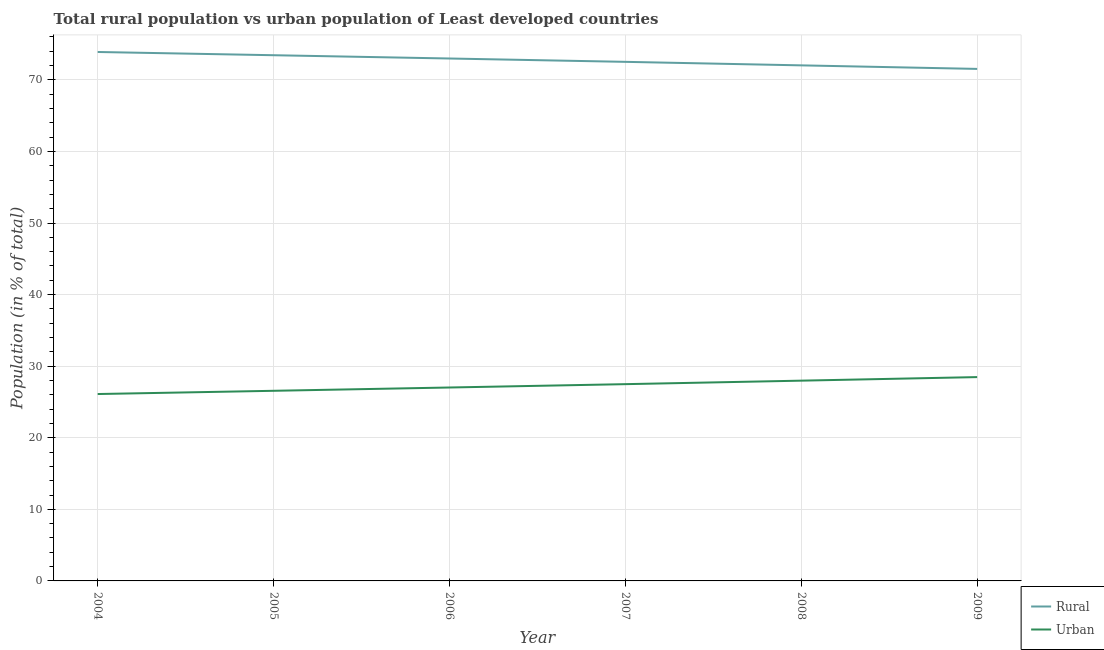Does the line corresponding to urban population intersect with the line corresponding to rural population?
Offer a terse response. No. What is the urban population in 2007?
Your answer should be compact. 27.49. Across all years, what is the maximum rural population?
Offer a very short reply. 73.89. Across all years, what is the minimum urban population?
Give a very brief answer. 26.11. What is the total urban population in the graph?
Your response must be concise. 163.63. What is the difference between the rural population in 2004 and that in 2007?
Offer a terse response. 1.38. What is the difference between the rural population in 2004 and the urban population in 2007?
Ensure brevity in your answer.  46.4. What is the average urban population per year?
Provide a short and direct response. 27.27. In the year 2009, what is the difference between the rural population and urban population?
Give a very brief answer. 43.05. What is the ratio of the rural population in 2005 to that in 2009?
Give a very brief answer. 1.03. Is the urban population in 2005 less than that in 2006?
Your answer should be compact. Yes. What is the difference between the highest and the second highest rural population?
Give a very brief answer. 0.45. What is the difference between the highest and the lowest urban population?
Give a very brief answer. 2.36. In how many years, is the urban population greater than the average urban population taken over all years?
Offer a terse response. 3. Is the sum of the urban population in 2006 and 2009 greater than the maximum rural population across all years?
Provide a succinct answer. No. Is the rural population strictly less than the urban population over the years?
Keep it short and to the point. No. How many lines are there?
Keep it short and to the point. 2. How many years are there in the graph?
Your answer should be very brief. 6. What is the difference between two consecutive major ticks on the Y-axis?
Offer a very short reply. 10. Are the values on the major ticks of Y-axis written in scientific E-notation?
Provide a short and direct response. No. Where does the legend appear in the graph?
Offer a terse response. Bottom right. How many legend labels are there?
Keep it short and to the point. 2. How are the legend labels stacked?
Offer a terse response. Vertical. What is the title of the graph?
Give a very brief answer. Total rural population vs urban population of Least developed countries. What is the label or title of the Y-axis?
Make the answer very short. Population (in % of total). What is the Population (in % of total) of Rural in 2004?
Give a very brief answer. 73.89. What is the Population (in % of total) of Urban in 2004?
Offer a very short reply. 26.11. What is the Population (in % of total) of Rural in 2005?
Ensure brevity in your answer.  73.44. What is the Population (in % of total) in Urban in 2005?
Make the answer very short. 26.56. What is the Population (in % of total) in Rural in 2006?
Give a very brief answer. 72.98. What is the Population (in % of total) of Urban in 2006?
Ensure brevity in your answer.  27.02. What is the Population (in % of total) in Rural in 2007?
Provide a succinct answer. 72.51. What is the Population (in % of total) of Urban in 2007?
Your answer should be compact. 27.49. What is the Population (in % of total) in Rural in 2008?
Keep it short and to the point. 72.02. What is the Population (in % of total) in Urban in 2008?
Keep it short and to the point. 27.98. What is the Population (in % of total) of Rural in 2009?
Keep it short and to the point. 71.53. What is the Population (in % of total) of Urban in 2009?
Your answer should be very brief. 28.47. Across all years, what is the maximum Population (in % of total) in Rural?
Offer a terse response. 73.89. Across all years, what is the maximum Population (in % of total) of Urban?
Give a very brief answer. 28.47. Across all years, what is the minimum Population (in % of total) in Rural?
Make the answer very short. 71.53. Across all years, what is the minimum Population (in % of total) in Urban?
Keep it short and to the point. 26.11. What is the total Population (in % of total) in Rural in the graph?
Offer a terse response. 436.37. What is the total Population (in % of total) in Urban in the graph?
Make the answer very short. 163.63. What is the difference between the Population (in % of total) of Rural in 2004 and that in 2005?
Provide a short and direct response. 0.45. What is the difference between the Population (in % of total) of Urban in 2004 and that in 2005?
Make the answer very short. -0.45. What is the difference between the Population (in % of total) in Rural in 2004 and that in 2006?
Your response must be concise. 0.91. What is the difference between the Population (in % of total) in Urban in 2004 and that in 2006?
Offer a terse response. -0.91. What is the difference between the Population (in % of total) in Rural in 2004 and that in 2007?
Your answer should be very brief. 1.38. What is the difference between the Population (in % of total) of Urban in 2004 and that in 2007?
Make the answer very short. -1.38. What is the difference between the Population (in % of total) of Rural in 2004 and that in 2008?
Provide a succinct answer. 1.87. What is the difference between the Population (in % of total) in Urban in 2004 and that in 2008?
Your answer should be very brief. -1.87. What is the difference between the Population (in % of total) of Rural in 2004 and that in 2009?
Your answer should be very brief. 2.36. What is the difference between the Population (in % of total) in Urban in 2004 and that in 2009?
Make the answer very short. -2.36. What is the difference between the Population (in % of total) in Rural in 2005 and that in 2006?
Provide a succinct answer. 0.46. What is the difference between the Population (in % of total) in Urban in 2005 and that in 2006?
Provide a short and direct response. -0.46. What is the difference between the Population (in % of total) of Rural in 2005 and that in 2007?
Provide a short and direct response. 0.93. What is the difference between the Population (in % of total) of Urban in 2005 and that in 2007?
Make the answer very short. -0.93. What is the difference between the Population (in % of total) in Rural in 2005 and that in 2008?
Keep it short and to the point. 1.42. What is the difference between the Population (in % of total) in Urban in 2005 and that in 2008?
Keep it short and to the point. -1.42. What is the difference between the Population (in % of total) of Rural in 2005 and that in 2009?
Your answer should be compact. 1.91. What is the difference between the Population (in % of total) of Urban in 2005 and that in 2009?
Your answer should be compact. -1.91. What is the difference between the Population (in % of total) of Rural in 2006 and that in 2007?
Offer a very short reply. 0.47. What is the difference between the Population (in % of total) of Urban in 2006 and that in 2007?
Offer a terse response. -0.47. What is the difference between the Population (in % of total) of Rural in 2006 and that in 2008?
Keep it short and to the point. 0.96. What is the difference between the Population (in % of total) of Urban in 2006 and that in 2008?
Offer a terse response. -0.96. What is the difference between the Population (in % of total) in Rural in 2006 and that in 2009?
Make the answer very short. 1.45. What is the difference between the Population (in % of total) in Urban in 2006 and that in 2009?
Your response must be concise. -1.45. What is the difference between the Population (in % of total) of Rural in 2007 and that in 2008?
Make the answer very short. 0.49. What is the difference between the Population (in % of total) of Urban in 2007 and that in 2008?
Ensure brevity in your answer.  -0.49. What is the difference between the Population (in % of total) in Rural in 2007 and that in 2009?
Provide a short and direct response. 0.99. What is the difference between the Population (in % of total) in Urban in 2007 and that in 2009?
Your answer should be very brief. -0.99. What is the difference between the Population (in % of total) of Rural in 2008 and that in 2009?
Your answer should be compact. 0.5. What is the difference between the Population (in % of total) in Urban in 2008 and that in 2009?
Provide a succinct answer. -0.5. What is the difference between the Population (in % of total) in Rural in 2004 and the Population (in % of total) in Urban in 2005?
Offer a terse response. 47.33. What is the difference between the Population (in % of total) in Rural in 2004 and the Population (in % of total) in Urban in 2006?
Your answer should be compact. 46.87. What is the difference between the Population (in % of total) of Rural in 2004 and the Population (in % of total) of Urban in 2007?
Provide a short and direct response. 46.4. What is the difference between the Population (in % of total) in Rural in 2004 and the Population (in % of total) in Urban in 2008?
Ensure brevity in your answer.  45.91. What is the difference between the Population (in % of total) of Rural in 2004 and the Population (in % of total) of Urban in 2009?
Ensure brevity in your answer.  45.42. What is the difference between the Population (in % of total) of Rural in 2005 and the Population (in % of total) of Urban in 2006?
Make the answer very short. 46.42. What is the difference between the Population (in % of total) of Rural in 2005 and the Population (in % of total) of Urban in 2007?
Offer a terse response. 45.95. What is the difference between the Population (in % of total) in Rural in 2005 and the Population (in % of total) in Urban in 2008?
Keep it short and to the point. 45.46. What is the difference between the Population (in % of total) in Rural in 2005 and the Population (in % of total) in Urban in 2009?
Your response must be concise. 44.97. What is the difference between the Population (in % of total) of Rural in 2006 and the Population (in % of total) of Urban in 2007?
Offer a terse response. 45.49. What is the difference between the Population (in % of total) in Rural in 2006 and the Population (in % of total) in Urban in 2008?
Offer a very short reply. 45. What is the difference between the Population (in % of total) in Rural in 2006 and the Population (in % of total) in Urban in 2009?
Keep it short and to the point. 44.51. What is the difference between the Population (in % of total) of Rural in 2007 and the Population (in % of total) of Urban in 2008?
Make the answer very short. 44.54. What is the difference between the Population (in % of total) in Rural in 2007 and the Population (in % of total) in Urban in 2009?
Make the answer very short. 44.04. What is the difference between the Population (in % of total) in Rural in 2008 and the Population (in % of total) in Urban in 2009?
Offer a very short reply. 43.55. What is the average Population (in % of total) of Rural per year?
Ensure brevity in your answer.  72.73. What is the average Population (in % of total) in Urban per year?
Your answer should be compact. 27.27. In the year 2004, what is the difference between the Population (in % of total) of Rural and Population (in % of total) of Urban?
Make the answer very short. 47.78. In the year 2005, what is the difference between the Population (in % of total) in Rural and Population (in % of total) in Urban?
Make the answer very short. 46.88. In the year 2006, what is the difference between the Population (in % of total) of Rural and Population (in % of total) of Urban?
Your response must be concise. 45.96. In the year 2007, what is the difference between the Population (in % of total) of Rural and Population (in % of total) of Urban?
Your answer should be compact. 45.03. In the year 2008, what is the difference between the Population (in % of total) in Rural and Population (in % of total) in Urban?
Your answer should be very brief. 44.05. In the year 2009, what is the difference between the Population (in % of total) in Rural and Population (in % of total) in Urban?
Give a very brief answer. 43.05. What is the ratio of the Population (in % of total) in Urban in 2004 to that in 2005?
Provide a succinct answer. 0.98. What is the ratio of the Population (in % of total) of Rural in 2004 to that in 2006?
Keep it short and to the point. 1.01. What is the ratio of the Population (in % of total) of Urban in 2004 to that in 2006?
Provide a short and direct response. 0.97. What is the ratio of the Population (in % of total) in Urban in 2004 to that in 2007?
Your answer should be compact. 0.95. What is the ratio of the Population (in % of total) of Rural in 2004 to that in 2008?
Ensure brevity in your answer.  1.03. What is the ratio of the Population (in % of total) of Urban in 2004 to that in 2008?
Keep it short and to the point. 0.93. What is the ratio of the Population (in % of total) in Rural in 2004 to that in 2009?
Your answer should be compact. 1.03. What is the ratio of the Population (in % of total) in Urban in 2004 to that in 2009?
Provide a succinct answer. 0.92. What is the ratio of the Population (in % of total) in Urban in 2005 to that in 2006?
Your answer should be very brief. 0.98. What is the ratio of the Population (in % of total) in Rural in 2005 to that in 2007?
Ensure brevity in your answer.  1.01. What is the ratio of the Population (in % of total) in Urban in 2005 to that in 2007?
Your answer should be compact. 0.97. What is the ratio of the Population (in % of total) in Rural in 2005 to that in 2008?
Give a very brief answer. 1.02. What is the ratio of the Population (in % of total) in Urban in 2005 to that in 2008?
Provide a succinct answer. 0.95. What is the ratio of the Population (in % of total) in Rural in 2005 to that in 2009?
Make the answer very short. 1.03. What is the ratio of the Population (in % of total) of Urban in 2005 to that in 2009?
Give a very brief answer. 0.93. What is the ratio of the Population (in % of total) of Rural in 2006 to that in 2007?
Your answer should be compact. 1.01. What is the ratio of the Population (in % of total) in Urban in 2006 to that in 2007?
Offer a terse response. 0.98. What is the ratio of the Population (in % of total) of Rural in 2006 to that in 2008?
Your answer should be very brief. 1.01. What is the ratio of the Population (in % of total) in Urban in 2006 to that in 2008?
Your answer should be very brief. 0.97. What is the ratio of the Population (in % of total) in Rural in 2006 to that in 2009?
Give a very brief answer. 1.02. What is the ratio of the Population (in % of total) of Urban in 2006 to that in 2009?
Keep it short and to the point. 0.95. What is the ratio of the Population (in % of total) in Rural in 2007 to that in 2008?
Your answer should be very brief. 1.01. What is the ratio of the Population (in % of total) of Urban in 2007 to that in 2008?
Give a very brief answer. 0.98. What is the ratio of the Population (in % of total) of Rural in 2007 to that in 2009?
Keep it short and to the point. 1.01. What is the ratio of the Population (in % of total) of Urban in 2007 to that in 2009?
Your answer should be compact. 0.97. What is the ratio of the Population (in % of total) of Rural in 2008 to that in 2009?
Give a very brief answer. 1.01. What is the ratio of the Population (in % of total) in Urban in 2008 to that in 2009?
Your answer should be very brief. 0.98. What is the difference between the highest and the second highest Population (in % of total) of Rural?
Offer a very short reply. 0.45. What is the difference between the highest and the second highest Population (in % of total) in Urban?
Your answer should be very brief. 0.5. What is the difference between the highest and the lowest Population (in % of total) in Rural?
Give a very brief answer. 2.36. What is the difference between the highest and the lowest Population (in % of total) in Urban?
Keep it short and to the point. 2.36. 